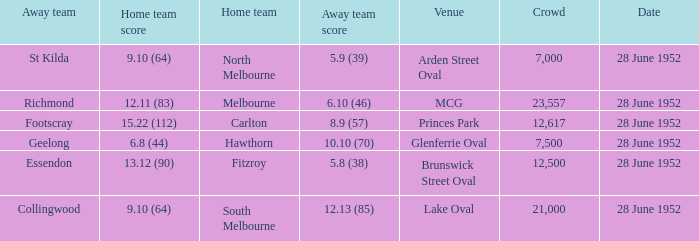What is the away team when north melbourne is at home? St Kilda. 